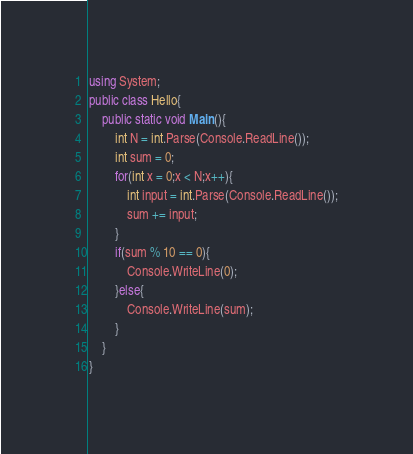<code> <loc_0><loc_0><loc_500><loc_500><_C#_>using System;
public class Hello{
    public static void Main(){
        int N = int.Parse(Console.ReadLine());
        int sum = 0;
        for(int x = 0;x < N;x++){
            int input = int.Parse(Console.ReadLine());
            sum += input;
        }
        if(sum % 10 == 0){
            Console.WriteLine(0);
        }else{
            Console.WriteLine(sum);
        }
    }
}
</code> 